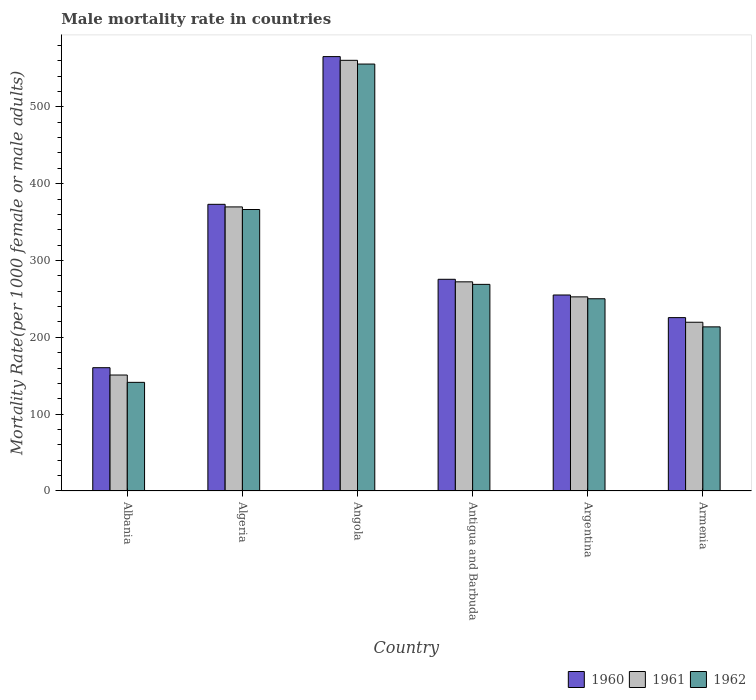How many groups of bars are there?
Offer a very short reply. 6. Are the number of bars per tick equal to the number of legend labels?
Ensure brevity in your answer.  Yes. Are the number of bars on each tick of the X-axis equal?
Give a very brief answer. Yes. How many bars are there on the 5th tick from the right?
Offer a terse response. 3. What is the label of the 2nd group of bars from the left?
Provide a short and direct response. Algeria. What is the male mortality rate in 1962 in Albania?
Provide a short and direct response. 141.41. Across all countries, what is the maximum male mortality rate in 1962?
Provide a short and direct response. 555.71. Across all countries, what is the minimum male mortality rate in 1961?
Your response must be concise. 150.94. In which country was the male mortality rate in 1960 maximum?
Ensure brevity in your answer.  Angola. In which country was the male mortality rate in 1961 minimum?
Provide a short and direct response. Albania. What is the total male mortality rate in 1961 in the graph?
Offer a very short reply. 1825.82. What is the difference between the male mortality rate in 1961 in Algeria and that in Argentina?
Your answer should be very brief. 117.1. What is the difference between the male mortality rate in 1960 in Albania and the male mortality rate in 1962 in Antigua and Barbuda?
Offer a terse response. -108.46. What is the average male mortality rate in 1962 per country?
Your response must be concise. 299.38. What is the difference between the male mortality rate of/in 1960 and male mortality rate of/in 1962 in Armenia?
Ensure brevity in your answer.  12.04. In how many countries, is the male mortality rate in 1962 greater than 40?
Make the answer very short. 6. What is the ratio of the male mortality rate in 1960 in Angola to that in Argentina?
Keep it short and to the point. 2.22. Is the male mortality rate in 1961 in Algeria less than that in Antigua and Barbuda?
Your response must be concise. No. What is the difference between the highest and the second highest male mortality rate in 1962?
Provide a short and direct response. 286.77. What is the difference between the highest and the lowest male mortality rate in 1961?
Provide a succinct answer. 409.62. In how many countries, is the male mortality rate in 1960 greater than the average male mortality rate in 1960 taken over all countries?
Provide a succinct answer. 2. Is the sum of the male mortality rate in 1961 in Algeria and Armenia greater than the maximum male mortality rate in 1962 across all countries?
Provide a short and direct response. Yes. How many bars are there?
Your answer should be very brief. 18. How many countries are there in the graph?
Make the answer very short. 6. Are the values on the major ticks of Y-axis written in scientific E-notation?
Offer a terse response. No. Does the graph contain any zero values?
Offer a terse response. No. Does the graph contain grids?
Your response must be concise. No. How many legend labels are there?
Offer a terse response. 3. How are the legend labels stacked?
Offer a terse response. Horizontal. What is the title of the graph?
Keep it short and to the point. Male mortality rate in countries. What is the label or title of the X-axis?
Make the answer very short. Country. What is the label or title of the Y-axis?
Make the answer very short. Mortality Rate(per 1000 female or male adults). What is the Mortality Rate(per 1000 female or male adults) in 1960 in Albania?
Provide a short and direct response. 160.48. What is the Mortality Rate(per 1000 female or male adults) of 1961 in Albania?
Provide a short and direct response. 150.94. What is the Mortality Rate(per 1000 female or male adults) in 1962 in Albania?
Ensure brevity in your answer.  141.41. What is the Mortality Rate(per 1000 female or male adults) of 1960 in Algeria?
Provide a succinct answer. 373.13. What is the Mortality Rate(per 1000 female or male adults) in 1961 in Algeria?
Make the answer very short. 369.76. What is the Mortality Rate(per 1000 female or male adults) in 1962 in Algeria?
Keep it short and to the point. 366.39. What is the Mortality Rate(per 1000 female or male adults) of 1960 in Angola?
Give a very brief answer. 565.41. What is the Mortality Rate(per 1000 female or male adults) in 1961 in Angola?
Give a very brief answer. 560.56. What is the Mortality Rate(per 1000 female or male adults) of 1962 in Angola?
Your answer should be compact. 555.71. What is the Mortality Rate(per 1000 female or male adults) in 1960 in Antigua and Barbuda?
Your response must be concise. 275.55. What is the Mortality Rate(per 1000 female or male adults) of 1961 in Antigua and Barbuda?
Offer a terse response. 272.25. What is the Mortality Rate(per 1000 female or male adults) in 1962 in Antigua and Barbuda?
Your answer should be compact. 268.94. What is the Mortality Rate(per 1000 female or male adults) of 1960 in Argentina?
Your answer should be very brief. 255.11. What is the Mortality Rate(per 1000 female or male adults) of 1961 in Argentina?
Make the answer very short. 252.66. What is the Mortality Rate(per 1000 female or male adults) in 1962 in Argentina?
Keep it short and to the point. 250.22. What is the Mortality Rate(per 1000 female or male adults) of 1960 in Armenia?
Offer a terse response. 225.67. What is the Mortality Rate(per 1000 female or male adults) of 1961 in Armenia?
Offer a terse response. 219.65. What is the Mortality Rate(per 1000 female or male adults) in 1962 in Armenia?
Provide a short and direct response. 213.63. Across all countries, what is the maximum Mortality Rate(per 1000 female or male adults) in 1960?
Provide a succinct answer. 565.41. Across all countries, what is the maximum Mortality Rate(per 1000 female or male adults) in 1961?
Make the answer very short. 560.56. Across all countries, what is the maximum Mortality Rate(per 1000 female or male adults) in 1962?
Offer a very short reply. 555.71. Across all countries, what is the minimum Mortality Rate(per 1000 female or male adults) in 1960?
Your answer should be very brief. 160.48. Across all countries, what is the minimum Mortality Rate(per 1000 female or male adults) of 1961?
Provide a succinct answer. 150.94. Across all countries, what is the minimum Mortality Rate(per 1000 female or male adults) of 1962?
Your answer should be very brief. 141.41. What is the total Mortality Rate(per 1000 female or male adults) in 1960 in the graph?
Your response must be concise. 1855.35. What is the total Mortality Rate(per 1000 female or male adults) in 1961 in the graph?
Your answer should be very brief. 1825.82. What is the total Mortality Rate(per 1000 female or male adults) of 1962 in the graph?
Keep it short and to the point. 1796.28. What is the difference between the Mortality Rate(per 1000 female or male adults) of 1960 in Albania and that in Algeria?
Keep it short and to the point. -212.65. What is the difference between the Mortality Rate(per 1000 female or male adults) in 1961 in Albania and that in Algeria?
Your response must be concise. -218.82. What is the difference between the Mortality Rate(per 1000 female or male adults) of 1962 in Albania and that in Algeria?
Provide a succinct answer. -224.98. What is the difference between the Mortality Rate(per 1000 female or male adults) of 1960 in Albania and that in Angola?
Offer a very short reply. -404.93. What is the difference between the Mortality Rate(per 1000 female or male adults) in 1961 in Albania and that in Angola?
Give a very brief answer. -409.62. What is the difference between the Mortality Rate(per 1000 female or male adults) of 1962 in Albania and that in Angola?
Your response must be concise. -414.3. What is the difference between the Mortality Rate(per 1000 female or male adults) of 1960 in Albania and that in Antigua and Barbuda?
Provide a short and direct response. -115.07. What is the difference between the Mortality Rate(per 1000 female or male adults) of 1961 in Albania and that in Antigua and Barbuda?
Provide a short and direct response. -121.3. What is the difference between the Mortality Rate(per 1000 female or male adults) of 1962 in Albania and that in Antigua and Barbuda?
Keep it short and to the point. -127.53. What is the difference between the Mortality Rate(per 1000 female or male adults) of 1960 in Albania and that in Argentina?
Offer a terse response. -94.63. What is the difference between the Mortality Rate(per 1000 female or male adults) of 1961 in Albania and that in Argentina?
Your answer should be compact. -101.72. What is the difference between the Mortality Rate(per 1000 female or male adults) of 1962 in Albania and that in Argentina?
Your answer should be very brief. -108.81. What is the difference between the Mortality Rate(per 1000 female or male adults) in 1960 in Albania and that in Armenia?
Make the answer very short. -65.19. What is the difference between the Mortality Rate(per 1000 female or male adults) of 1961 in Albania and that in Armenia?
Ensure brevity in your answer.  -68.71. What is the difference between the Mortality Rate(per 1000 female or male adults) of 1962 in Albania and that in Armenia?
Offer a very short reply. -72.22. What is the difference between the Mortality Rate(per 1000 female or male adults) in 1960 in Algeria and that in Angola?
Offer a very short reply. -192.28. What is the difference between the Mortality Rate(per 1000 female or male adults) of 1961 in Algeria and that in Angola?
Your answer should be compact. -190.8. What is the difference between the Mortality Rate(per 1000 female or male adults) in 1962 in Algeria and that in Angola?
Provide a succinct answer. -189.32. What is the difference between the Mortality Rate(per 1000 female or male adults) in 1960 in Algeria and that in Antigua and Barbuda?
Give a very brief answer. 97.58. What is the difference between the Mortality Rate(per 1000 female or male adults) of 1961 in Algeria and that in Antigua and Barbuda?
Offer a terse response. 97.51. What is the difference between the Mortality Rate(per 1000 female or male adults) in 1962 in Algeria and that in Antigua and Barbuda?
Provide a short and direct response. 97.45. What is the difference between the Mortality Rate(per 1000 female or male adults) in 1960 in Algeria and that in Argentina?
Keep it short and to the point. 118.02. What is the difference between the Mortality Rate(per 1000 female or male adults) of 1961 in Algeria and that in Argentina?
Provide a succinct answer. 117.1. What is the difference between the Mortality Rate(per 1000 female or male adults) in 1962 in Algeria and that in Argentina?
Your answer should be compact. 116.17. What is the difference between the Mortality Rate(per 1000 female or male adults) of 1960 in Algeria and that in Armenia?
Offer a terse response. 147.46. What is the difference between the Mortality Rate(per 1000 female or male adults) of 1961 in Algeria and that in Armenia?
Ensure brevity in your answer.  150.11. What is the difference between the Mortality Rate(per 1000 female or male adults) of 1962 in Algeria and that in Armenia?
Provide a succinct answer. 152.76. What is the difference between the Mortality Rate(per 1000 female or male adults) in 1960 in Angola and that in Antigua and Barbuda?
Offer a very short reply. 289.86. What is the difference between the Mortality Rate(per 1000 female or male adults) in 1961 in Angola and that in Antigua and Barbuda?
Offer a terse response. 288.31. What is the difference between the Mortality Rate(per 1000 female or male adults) of 1962 in Angola and that in Antigua and Barbuda?
Give a very brief answer. 286.77. What is the difference between the Mortality Rate(per 1000 female or male adults) of 1960 in Angola and that in Argentina?
Your answer should be very brief. 310.3. What is the difference between the Mortality Rate(per 1000 female or male adults) of 1961 in Angola and that in Argentina?
Your response must be concise. 307.9. What is the difference between the Mortality Rate(per 1000 female or male adults) in 1962 in Angola and that in Argentina?
Your response must be concise. 305.49. What is the difference between the Mortality Rate(per 1000 female or male adults) in 1960 in Angola and that in Armenia?
Your response must be concise. 339.74. What is the difference between the Mortality Rate(per 1000 female or male adults) in 1961 in Angola and that in Armenia?
Offer a very short reply. 340.91. What is the difference between the Mortality Rate(per 1000 female or male adults) of 1962 in Angola and that in Armenia?
Provide a succinct answer. 342.08. What is the difference between the Mortality Rate(per 1000 female or male adults) in 1960 in Antigua and Barbuda and that in Argentina?
Offer a very short reply. 20.44. What is the difference between the Mortality Rate(per 1000 female or male adults) in 1961 in Antigua and Barbuda and that in Argentina?
Offer a terse response. 19.58. What is the difference between the Mortality Rate(per 1000 female or male adults) of 1962 in Antigua and Barbuda and that in Argentina?
Provide a succinct answer. 18.72. What is the difference between the Mortality Rate(per 1000 female or male adults) of 1960 in Antigua and Barbuda and that in Armenia?
Keep it short and to the point. 49.88. What is the difference between the Mortality Rate(per 1000 female or male adults) of 1961 in Antigua and Barbuda and that in Armenia?
Your answer should be very brief. 52.6. What is the difference between the Mortality Rate(per 1000 female or male adults) of 1962 in Antigua and Barbuda and that in Armenia?
Provide a succinct answer. 55.31. What is the difference between the Mortality Rate(per 1000 female or male adults) in 1960 in Argentina and that in Armenia?
Ensure brevity in your answer.  29.44. What is the difference between the Mortality Rate(per 1000 female or male adults) in 1961 in Argentina and that in Armenia?
Offer a terse response. 33.02. What is the difference between the Mortality Rate(per 1000 female or male adults) of 1962 in Argentina and that in Armenia?
Give a very brief answer. 36.59. What is the difference between the Mortality Rate(per 1000 female or male adults) in 1960 in Albania and the Mortality Rate(per 1000 female or male adults) in 1961 in Algeria?
Give a very brief answer. -209.28. What is the difference between the Mortality Rate(per 1000 female or male adults) of 1960 in Albania and the Mortality Rate(per 1000 female or male adults) of 1962 in Algeria?
Give a very brief answer. -205.91. What is the difference between the Mortality Rate(per 1000 female or male adults) of 1961 in Albania and the Mortality Rate(per 1000 female or male adults) of 1962 in Algeria?
Offer a terse response. -215.44. What is the difference between the Mortality Rate(per 1000 female or male adults) of 1960 in Albania and the Mortality Rate(per 1000 female or male adults) of 1961 in Angola?
Offer a very short reply. -400.08. What is the difference between the Mortality Rate(per 1000 female or male adults) of 1960 in Albania and the Mortality Rate(per 1000 female or male adults) of 1962 in Angola?
Provide a short and direct response. -395.23. What is the difference between the Mortality Rate(per 1000 female or male adults) of 1961 in Albania and the Mortality Rate(per 1000 female or male adults) of 1962 in Angola?
Your answer should be compact. -404.77. What is the difference between the Mortality Rate(per 1000 female or male adults) in 1960 in Albania and the Mortality Rate(per 1000 female or male adults) in 1961 in Antigua and Barbuda?
Keep it short and to the point. -111.76. What is the difference between the Mortality Rate(per 1000 female or male adults) of 1960 in Albania and the Mortality Rate(per 1000 female or male adults) of 1962 in Antigua and Barbuda?
Your response must be concise. -108.46. What is the difference between the Mortality Rate(per 1000 female or male adults) of 1961 in Albania and the Mortality Rate(per 1000 female or male adults) of 1962 in Antigua and Barbuda?
Your answer should be compact. -118. What is the difference between the Mortality Rate(per 1000 female or male adults) in 1960 in Albania and the Mortality Rate(per 1000 female or male adults) in 1961 in Argentina?
Give a very brief answer. -92.18. What is the difference between the Mortality Rate(per 1000 female or male adults) of 1960 in Albania and the Mortality Rate(per 1000 female or male adults) of 1962 in Argentina?
Offer a very short reply. -89.74. What is the difference between the Mortality Rate(per 1000 female or male adults) in 1961 in Albania and the Mortality Rate(per 1000 female or male adults) in 1962 in Argentina?
Provide a short and direct response. -99.28. What is the difference between the Mortality Rate(per 1000 female or male adults) of 1960 in Albania and the Mortality Rate(per 1000 female or male adults) of 1961 in Armenia?
Your answer should be compact. -59.17. What is the difference between the Mortality Rate(per 1000 female or male adults) of 1960 in Albania and the Mortality Rate(per 1000 female or male adults) of 1962 in Armenia?
Offer a terse response. -53.15. What is the difference between the Mortality Rate(per 1000 female or male adults) in 1961 in Albania and the Mortality Rate(per 1000 female or male adults) in 1962 in Armenia?
Ensure brevity in your answer.  -62.68. What is the difference between the Mortality Rate(per 1000 female or male adults) of 1960 in Algeria and the Mortality Rate(per 1000 female or male adults) of 1961 in Angola?
Your answer should be compact. -187.43. What is the difference between the Mortality Rate(per 1000 female or male adults) in 1960 in Algeria and the Mortality Rate(per 1000 female or male adults) in 1962 in Angola?
Make the answer very short. -182.58. What is the difference between the Mortality Rate(per 1000 female or male adults) in 1961 in Algeria and the Mortality Rate(per 1000 female or male adults) in 1962 in Angola?
Offer a terse response. -185.95. What is the difference between the Mortality Rate(per 1000 female or male adults) in 1960 in Algeria and the Mortality Rate(per 1000 female or male adults) in 1961 in Antigua and Barbuda?
Ensure brevity in your answer.  100.89. What is the difference between the Mortality Rate(per 1000 female or male adults) of 1960 in Algeria and the Mortality Rate(per 1000 female or male adults) of 1962 in Antigua and Barbuda?
Offer a terse response. 104.19. What is the difference between the Mortality Rate(per 1000 female or male adults) of 1961 in Algeria and the Mortality Rate(per 1000 female or male adults) of 1962 in Antigua and Barbuda?
Keep it short and to the point. 100.82. What is the difference between the Mortality Rate(per 1000 female or male adults) in 1960 in Algeria and the Mortality Rate(per 1000 female or male adults) in 1961 in Argentina?
Provide a succinct answer. 120.47. What is the difference between the Mortality Rate(per 1000 female or male adults) of 1960 in Algeria and the Mortality Rate(per 1000 female or male adults) of 1962 in Argentina?
Your response must be concise. 122.91. What is the difference between the Mortality Rate(per 1000 female or male adults) of 1961 in Algeria and the Mortality Rate(per 1000 female or male adults) of 1962 in Argentina?
Give a very brief answer. 119.54. What is the difference between the Mortality Rate(per 1000 female or male adults) of 1960 in Algeria and the Mortality Rate(per 1000 female or male adults) of 1961 in Armenia?
Your response must be concise. 153.48. What is the difference between the Mortality Rate(per 1000 female or male adults) in 1960 in Algeria and the Mortality Rate(per 1000 female or male adults) in 1962 in Armenia?
Ensure brevity in your answer.  159.51. What is the difference between the Mortality Rate(per 1000 female or male adults) in 1961 in Algeria and the Mortality Rate(per 1000 female or male adults) in 1962 in Armenia?
Make the answer very short. 156.13. What is the difference between the Mortality Rate(per 1000 female or male adults) of 1960 in Angola and the Mortality Rate(per 1000 female or male adults) of 1961 in Antigua and Barbuda?
Offer a terse response. 293.17. What is the difference between the Mortality Rate(per 1000 female or male adults) in 1960 in Angola and the Mortality Rate(per 1000 female or male adults) in 1962 in Antigua and Barbuda?
Offer a terse response. 296.47. What is the difference between the Mortality Rate(per 1000 female or male adults) of 1961 in Angola and the Mortality Rate(per 1000 female or male adults) of 1962 in Antigua and Barbuda?
Your answer should be very brief. 291.62. What is the difference between the Mortality Rate(per 1000 female or male adults) of 1960 in Angola and the Mortality Rate(per 1000 female or male adults) of 1961 in Argentina?
Offer a very short reply. 312.75. What is the difference between the Mortality Rate(per 1000 female or male adults) of 1960 in Angola and the Mortality Rate(per 1000 female or male adults) of 1962 in Argentina?
Keep it short and to the point. 315.19. What is the difference between the Mortality Rate(per 1000 female or male adults) in 1961 in Angola and the Mortality Rate(per 1000 female or male adults) in 1962 in Argentina?
Offer a terse response. 310.34. What is the difference between the Mortality Rate(per 1000 female or male adults) of 1960 in Angola and the Mortality Rate(per 1000 female or male adults) of 1961 in Armenia?
Offer a terse response. 345.76. What is the difference between the Mortality Rate(per 1000 female or male adults) in 1960 in Angola and the Mortality Rate(per 1000 female or male adults) in 1962 in Armenia?
Make the answer very short. 351.78. What is the difference between the Mortality Rate(per 1000 female or male adults) of 1961 in Angola and the Mortality Rate(per 1000 female or male adults) of 1962 in Armenia?
Provide a succinct answer. 346.93. What is the difference between the Mortality Rate(per 1000 female or male adults) in 1960 in Antigua and Barbuda and the Mortality Rate(per 1000 female or male adults) in 1961 in Argentina?
Give a very brief answer. 22.89. What is the difference between the Mortality Rate(per 1000 female or male adults) of 1960 in Antigua and Barbuda and the Mortality Rate(per 1000 female or male adults) of 1962 in Argentina?
Provide a succinct answer. 25.33. What is the difference between the Mortality Rate(per 1000 female or male adults) in 1961 in Antigua and Barbuda and the Mortality Rate(per 1000 female or male adults) in 1962 in Argentina?
Your answer should be compact. 22.03. What is the difference between the Mortality Rate(per 1000 female or male adults) in 1960 in Antigua and Barbuda and the Mortality Rate(per 1000 female or male adults) in 1961 in Armenia?
Offer a very short reply. 55.9. What is the difference between the Mortality Rate(per 1000 female or male adults) of 1960 in Antigua and Barbuda and the Mortality Rate(per 1000 female or male adults) of 1962 in Armenia?
Your answer should be compact. 61.93. What is the difference between the Mortality Rate(per 1000 female or male adults) in 1961 in Antigua and Barbuda and the Mortality Rate(per 1000 female or male adults) in 1962 in Armenia?
Provide a short and direct response. 58.62. What is the difference between the Mortality Rate(per 1000 female or male adults) of 1960 in Argentina and the Mortality Rate(per 1000 female or male adults) of 1961 in Armenia?
Keep it short and to the point. 35.46. What is the difference between the Mortality Rate(per 1000 female or male adults) of 1960 in Argentina and the Mortality Rate(per 1000 female or male adults) of 1962 in Armenia?
Make the answer very short. 41.48. What is the difference between the Mortality Rate(per 1000 female or male adults) of 1961 in Argentina and the Mortality Rate(per 1000 female or male adults) of 1962 in Armenia?
Provide a succinct answer. 39.04. What is the average Mortality Rate(per 1000 female or male adults) in 1960 per country?
Your answer should be compact. 309.23. What is the average Mortality Rate(per 1000 female or male adults) in 1961 per country?
Offer a terse response. 304.3. What is the average Mortality Rate(per 1000 female or male adults) in 1962 per country?
Your response must be concise. 299.38. What is the difference between the Mortality Rate(per 1000 female or male adults) of 1960 and Mortality Rate(per 1000 female or male adults) of 1961 in Albania?
Provide a short and direct response. 9.54. What is the difference between the Mortality Rate(per 1000 female or male adults) in 1960 and Mortality Rate(per 1000 female or male adults) in 1962 in Albania?
Provide a short and direct response. 19.08. What is the difference between the Mortality Rate(per 1000 female or male adults) in 1961 and Mortality Rate(per 1000 female or male adults) in 1962 in Albania?
Your answer should be compact. 9.54. What is the difference between the Mortality Rate(per 1000 female or male adults) in 1960 and Mortality Rate(per 1000 female or male adults) in 1961 in Algeria?
Your answer should be very brief. 3.37. What is the difference between the Mortality Rate(per 1000 female or male adults) in 1960 and Mortality Rate(per 1000 female or male adults) in 1962 in Algeria?
Provide a short and direct response. 6.75. What is the difference between the Mortality Rate(per 1000 female or male adults) of 1961 and Mortality Rate(per 1000 female or male adults) of 1962 in Algeria?
Keep it short and to the point. 3.37. What is the difference between the Mortality Rate(per 1000 female or male adults) in 1960 and Mortality Rate(per 1000 female or male adults) in 1961 in Angola?
Keep it short and to the point. 4.85. What is the difference between the Mortality Rate(per 1000 female or male adults) of 1960 and Mortality Rate(per 1000 female or male adults) of 1962 in Angola?
Provide a short and direct response. 9.7. What is the difference between the Mortality Rate(per 1000 female or male adults) of 1961 and Mortality Rate(per 1000 female or male adults) of 1962 in Angola?
Your answer should be compact. 4.85. What is the difference between the Mortality Rate(per 1000 female or male adults) in 1960 and Mortality Rate(per 1000 female or male adults) in 1961 in Antigua and Barbuda?
Make the answer very short. 3.31. What is the difference between the Mortality Rate(per 1000 female or male adults) in 1960 and Mortality Rate(per 1000 female or male adults) in 1962 in Antigua and Barbuda?
Your answer should be very brief. 6.61. What is the difference between the Mortality Rate(per 1000 female or male adults) in 1961 and Mortality Rate(per 1000 female or male adults) in 1962 in Antigua and Barbuda?
Make the answer very short. 3.31. What is the difference between the Mortality Rate(per 1000 female or male adults) of 1960 and Mortality Rate(per 1000 female or male adults) of 1961 in Argentina?
Give a very brief answer. 2.44. What is the difference between the Mortality Rate(per 1000 female or male adults) of 1960 and Mortality Rate(per 1000 female or male adults) of 1962 in Argentina?
Make the answer very short. 4.89. What is the difference between the Mortality Rate(per 1000 female or male adults) of 1961 and Mortality Rate(per 1000 female or male adults) of 1962 in Argentina?
Give a very brief answer. 2.44. What is the difference between the Mortality Rate(per 1000 female or male adults) of 1960 and Mortality Rate(per 1000 female or male adults) of 1961 in Armenia?
Your answer should be compact. 6.02. What is the difference between the Mortality Rate(per 1000 female or male adults) of 1960 and Mortality Rate(per 1000 female or male adults) of 1962 in Armenia?
Offer a terse response. 12.04. What is the difference between the Mortality Rate(per 1000 female or male adults) in 1961 and Mortality Rate(per 1000 female or male adults) in 1962 in Armenia?
Provide a succinct answer. 6.02. What is the ratio of the Mortality Rate(per 1000 female or male adults) of 1960 in Albania to that in Algeria?
Offer a terse response. 0.43. What is the ratio of the Mortality Rate(per 1000 female or male adults) in 1961 in Albania to that in Algeria?
Your response must be concise. 0.41. What is the ratio of the Mortality Rate(per 1000 female or male adults) in 1962 in Albania to that in Algeria?
Offer a terse response. 0.39. What is the ratio of the Mortality Rate(per 1000 female or male adults) in 1960 in Albania to that in Angola?
Offer a terse response. 0.28. What is the ratio of the Mortality Rate(per 1000 female or male adults) of 1961 in Albania to that in Angola?
Keep it short and to the point. 0.27. What is the ratio of the Mortality Rate(per 1000 female or male adults) of 1962 in Albania to that in Angola?
Keep it short and to the point. 0.25. What is the ratio of the Mortality Rate(per 1000 female or male adults) of 1960 in Albania to that in Antigua and Barbuda?
Provide a succinct answer. 0.58. What is the ratio of the Mortality Rate(per 1000 female or male adults) of 1961 in Albania to that in Antigua and Barbuda?
Your answer should be compact. 0.55. What is the ratio of the Mortality Rate(per 1000 female or male adults) of 1962 in Albania to that in Antigua and Barbuda?
Provide a short and direct response. 0.53. What is the ratio of the Mortality Rate(per 1000 female or male adults) in 1960 in Albania to that in Argentina?
Your response must be concise. 0.63. What is the ratio of the Mortality Rate(per 1000 female or male adults) in 1961 in Albania to that in Argentina?
Ensure brevity in your answer.  0.6. What is the ratio of the Mortality Rate(per 1000 female or male adults) of 1962 in Albania to that in Argentina?
Keep it short and to the point. 0.57. What is the ratio of the Mortality Rate(per 1000 female or male adults) of 1960 in Albania to that in Armenia?
Give a very brief answer. 0.71. What is the ratio of the Mortality Rate(per 1000 female or male adults) of 1961 in Albania to that in Armenia?
Offer a very short reply. 0.69. What is the ratio of the Mortality Rate(per 1000 female or male adults) of 1962 in Albania to that in Armenia?
Ensure brevity in your answer.  0.66. What is the ratio of the Mortality Rate(per 1000 female or male adults) of 1960 in Algeria to that in Angola?
Ensure brevity in your answer.  0.66. What is the ratio of the Mortality Rate(per 1000 female or male adults) of 1961 in Algeria to that in Angola?
Offer a very short reply. 0.66. What is the ratio of the Mortality Rate(per 1000 female or male adults) of 1962 in Algeria to that in Angola?
Your answer should be compact. 0.66. What is the ratio of the Mortality Rate(per 1000 female or male adults) of 1960 in Algeria to that in Antigua and Barbuda?
Make the answer very short. 1.35. What is the ratio of the Mortality Rate(per 1000 female or male adults) of 1961 in Algeria to that in Antigua and Barbuda?
Keep it short and to the point. 1.36. What is the ratio of the Mortality Rate(per 1000 female or male adults) of 1962 in Algeria to that in Antigua and Barbuda?
Your answer should be compact. 1.36. What is the ratio of the Mortality Rate(per 1000 female or male adults) of 1960 in Algeria to that in Argentina?
Offer a very short reply. 1.46. What is the ratio of the Mortality Rate(per 1000 female or male adults) in 1961 in Algeria to that in Argentina?
Ensure brevity in your answer.  1.46. What is the ratio of the Mortality Rate(per 1000 female or male adults) in 1962 in Algeria to that in Argentina?
Your answer should be very brief. 1.46. What is the ratio of the Mortality Rate(per 1000 female or male adults) in 1960 in Algeria to that in Armenia?
Give a very brief answer. 1.65. What is the ratio of the Mortality Rate(per 1000 female or male adults) in 1961 in Algeria to that in Armenia?
Your answer should be very brief. 1.68. What is the ratio of the Mortality Rate(per 1000 female or male adults) of 1962 in Algeria to that in Armenia?
Keep it short and to the point. 1.72. What is the ratio of the Mortality Rate(per 1000 female or male adults) in 1960 in Angola to that in Antigua and Barbuda?
Your answer should be very brief. 2.05. What is the ratio of the Mortality Rate(per 1000 female or male adults) of 1961 in Angola to that in Antigua and Barbuda?
Your answer should be very brief. 2.06. What is the ratio of the Mortality Rate(per 1000 female or male adults) of 1962 in Angola to that in Antigua and Barbuda?
Make the answer very short. 2.07. What is the ratio of the Mortality Rate(per 1000 female or male adults) of 1960 in Angola to that in Argentina?
Make the answer very short. 2.22. What is the ratio of the Mortality Rate(per 1000 female or male adults) in 1961 in Angola to that in Argentina?
Offer a very short reply. 2.22. What is the ratio of the Mortality Rate(per 1000 female or male adults) in 1962 in Angola to that in Argentina?
Your answer should be compact. 2.22. What is the ratio of the Mortality Rate(per 1000 female or male adults) of 1960 in Angola to that in Armenia?
Provide a succinct answer. 2.51. What is the ratio of the Mortality Rate(per 1000 female or male adults) of 1961 in Angola to that in Armenia?
Your answer should be very brief. 2.55. What is the ratio of the Mortality Rate(per 1000 female or male adults) in 1962 in Angola to that in Armenia?
Provide a succinct answer. 2.6. What is the ratio of the Mortality Rate(per 1000 female or male adults) in 1960 in Antigua and Barbuda to that in Argentina?
Your response must be concise. 1.08. What is the ratio of the Mortality Rate(per 1000 female or male adults) of 1961 in Antigua and Barbuda to that in Argentina?
Your answer should be compact. 1.08. What is the ratio of the Mortality Rate(per 1000 female or male adults) of 1962 in Antigua and Barbuda to that in Argentina?
Give a very brief answer. 1.07. What is the ratio of the Mortality Rate(per 1000 female or male adults) in 1960 in Antigua and Barbuda to that in Armenia?
Your response must be concise. 1.22. What is the ratio of the Mortality Rate(per 1000 female or male adults) of 1961 in Antigua and Barbuda to that in Armenia?
Keep it short and to the point. 1.24. What is the ratio of the Mortality Rate(per 1000 female or male adults) of 1962 in Antigua and Barbuda to that in Armenia?
Keep it short and to the point. 1.26. What is the ratio of the Mortality Rate(per 1000 female or male adults) in 1960 in Argentina to that in Armenia?
Make the answer very short. 1.13. What is the ratio of the Mortality Rate(per 1000 female or male adults) in 1961 in Argentina to that in Armenia?
Ensure brevity in your answer.  1.15. What is the ratio of the Mortality Rate(per 1000 female or male adults) of 1962 in Argentina to that in Armenia?
Give a very brief answer. 1.17. What is the difference between the highest and the second highest Mortality Rate(per 1000 female or male adults) in 1960?
Your response must be concise. 192.28. What is the difference between the highest and the second highest Mortality Rate(per 1000 female or male adults) of 1961?
Provide a short and direct response. 190.8. What is the difference between the highest and the second highest Mortality Rate(per 1000 female or male adults) in 1962?
Ensure brevity in your answer.  189.32. What is the difference between the highest and the lowest Mortality Rate(per 1000 female or male adults) in 1960?
Your answer should be very brief. 404.93. What is the difference between the highest and the lowest Mortality Rate(per 1000 female or male adults) in 1961?
Offer a terse response. 409.62. What is the difference between the highest and the lowest Mortality Rate(per 1000 female or male adults) in 1962?
Your answer should be very brief. 414.3. 